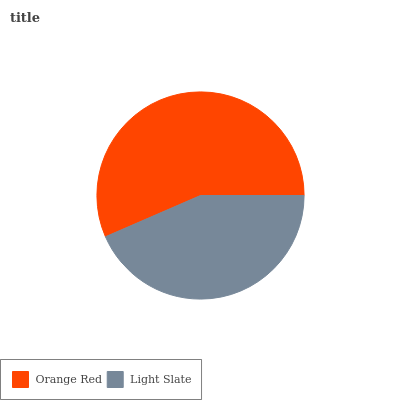Is Light Slate the minimum?
Answer yes or no. Yes. Is Orange Red the maximum?
Answer yes or no. Yes. Is Light Slate the maximum?
Answer yes or no. No. Is Orange Red greater than Light Slate?
Answer yes or no. Yes. Is Light Slate less than Orange Red?
Answer yes or no. Yes. Is Light Slate greater than Orange Red?
Answer yes or no. No. Is Orange Red less than Light Slate?
Answer yes or no. No. Is Orange Red the high median?
Answer yes or no. Yes. Is Light Slate the low median?
Answer yes or no. Yes. Is Light Slate the high median?
Answer yes or no. No. Is Orange Red the low median?
Answer yes or no. No. 